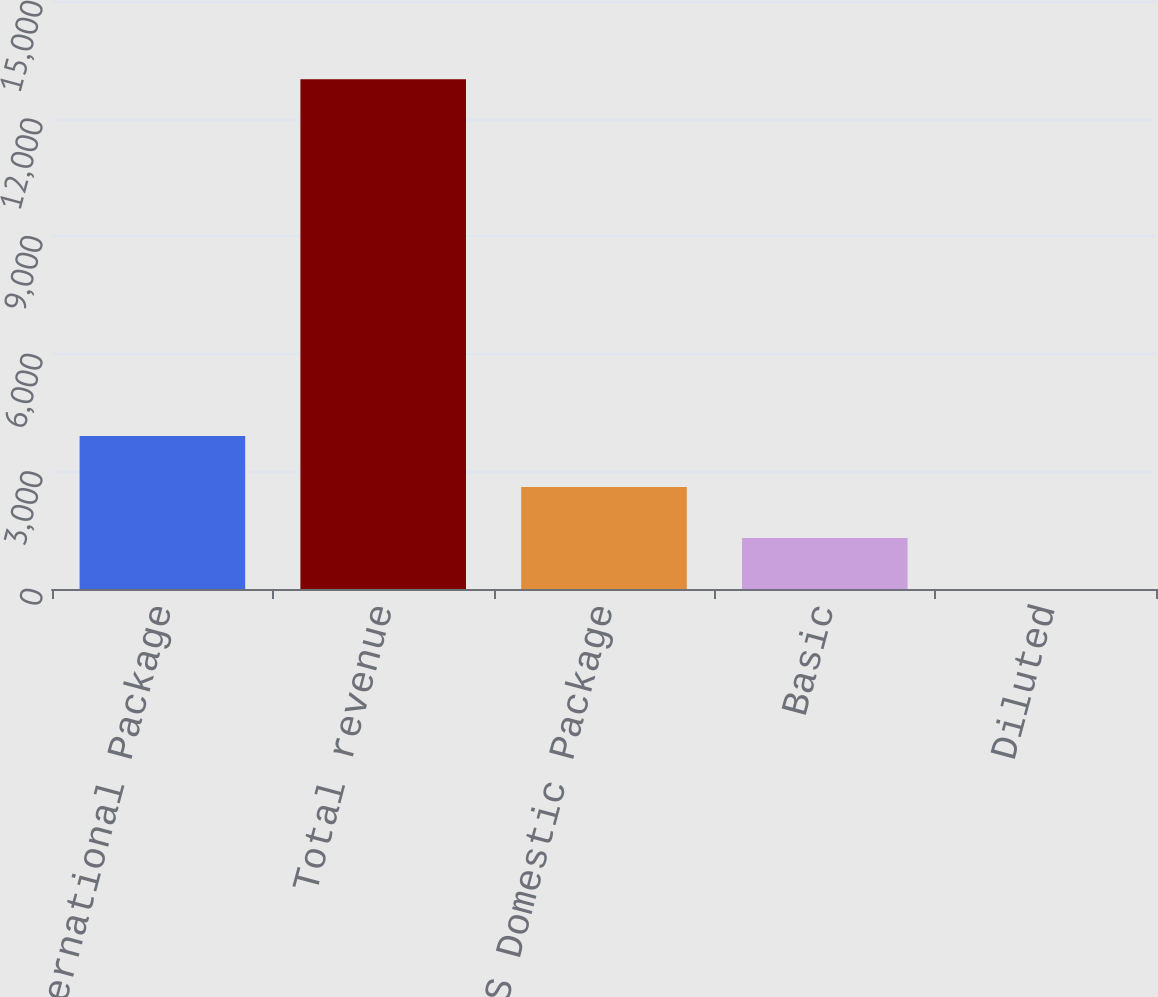Convert chart to OTSL. <chart><loc_0><loc_0><loc_500><loc_500><bar_chart><fcel>International Package<fcel>Total revenue<fcel>US Domestic Package<fcel>Basic<fcel>Diluted<nl><fcel>3900.9<fcel>13001<fcel>2600.89<fcel>1300.87<fcel>0.85<nl></chart> 